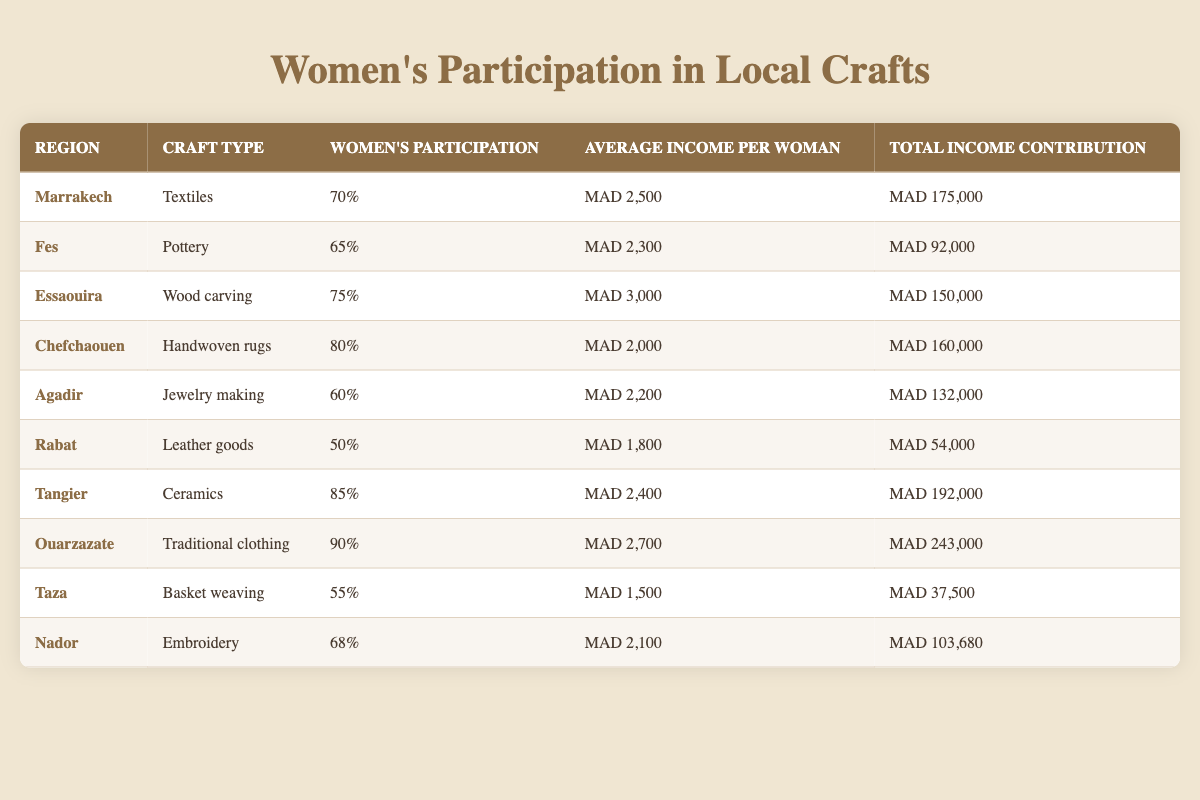What region has the highest percentage of women's participation in crafts? The table shows that Ouarzazate has the highest women's participation percentage at 90%.
Answer: Ouarzazate What is the average income per woman in Essaouira? According to the table, the average income per woman in Essaouira is 3,000 MAD.
Answer: 3,000 MAD Which region contributes the least total income from women's crafts? The total income contribution for Taza is 37,500 MAD, which is the lowest in the table.
Answer: Taza How many regions have more than 80% women's participation? By analyzing the table, we see that only Ouarzazate (90%), Tangier (85%), and Chefchaouen (80%) meet this criterion, making it three regions.
Answer: 3 What is the total income contribution of Marrakech and Essaouira combined? The total income for Marrakech is 175,000 MAD and for Essaouira it's 150,000 MAD. Adding these gives 175,000 + 150,000 = 325,000 MAD.
Answer: 325,000 MAD Is the average income per woman in Rabat higher than in Fes? The average income per woman in Rabat is 1,800 MAD, while in Fes it is 2,300 MAD. Since 1,800 is less than 2,300, the answer is no.
Answer: No Which craft type has the highest average income per woman? Looking at the table, the craft type of Wood carving in Essaouira has the highest average income, which is 3,000 MAD.
Answer: Wood carving What is the difference in total income contribution between Ouarzazate and Tangier? Ouarzazate contributes 243,000 MAD, and Tangier contributes 192,000 MAD. The difference is 243,000 - 192,000 = 51,000 MAD.
Answer: 51,000 MAD Are there more regions where women's participation is above 70% than below 70%? The regions above 70% participation are Marrakech, Essaouira, Chefchaouen, Tangier, and Ouarzazate (5 regions), while those below are Fes, Agadir, Rabat, Taza, and Nador (5 regions). Thus, it is not true.
Answer: No What is the average participation percentage of women across all regions? To find the average, we add all the percentages: 70 + 65 + 75 + 80 + 60 + 50 + 85 + 90 + 55 + 68 =  78. The average is 780/10 = 78%.
Answer: 78% 